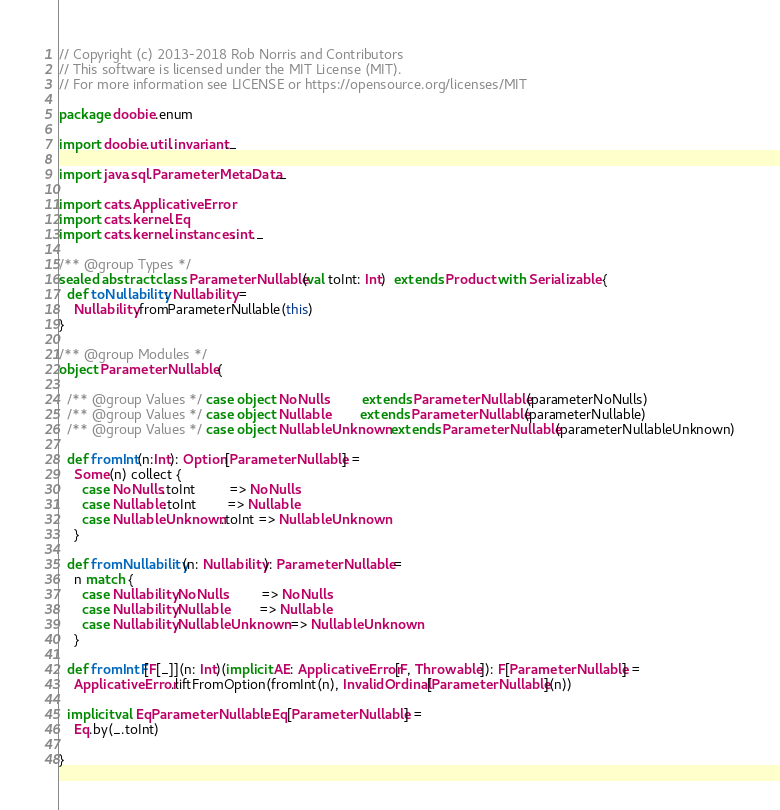<code> <loc_0><loc_0><loc_500><loc_500><_Scala_>// Copyright (c) 2013-2018 Rob Norris and Contributors
// This software is licensed under the MIT License (MIT).
// For more information see LICENSE or https://opensource.org/licenses/MIT

package doobie.enum

import doobie.util.invariant._

import java.sql.ParameterMetaData._

import cats.ApplicativeError
import cats.kernel.Eq
import cats.kernel.instances.int._

/** @group Types */
sealed abstract class ParameterNullable(val toInt: Int)  extends Product with Serializable {
  def toNullability: Nullability =
    Nullability.fromParameterNullable(this)
}

/** @group Modules */
object ParameterNullable {

  /** @group Values */ case object NoNulls         extends ParameterNullable(parameterNoNulls)
  /** @group Values */ case object Nullable        extends ParameterNullable(parameterNullable)
  /** @group Values */ case object NullableUnknown extends ParameterNullable(parameterNullableUnknown)

  def fromInt(n:Int): Option[ParameterNullable] =
    Some(n) collect {
      case NoNulls.toInt         => NoNulls
      case Nullable.toInt        => Nullable
      case NullableUnknown.toInt => NullableUnknown
    }

  def fromNullability(n: Nullability): ParameterNullable =
    n match {
      case Nullability.NoNulls         => NoNulls
      case Nullability.Nullable        => Nullable
      case Nullability.NullableUnknown => NullableUnknown
    }

  def fromIntF[F[_]](n: Int)(implicit AE: ApplicativeError[F, Throwable]): F[ParameterNullable] =
    ApplicativeError.liftFromOption(fromInt(n), InvalidOrdinal[ParameterNullable](n))

  implicit val EqParameterNullable: Eq[ParameterNullable] =
    Eq.by(_.toInt)

}
</code> 